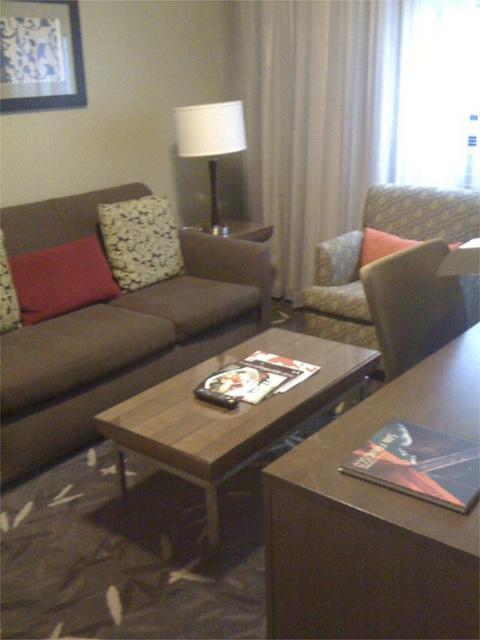Is this a small living room?
Short answer required. Yes. Is the lamp on or off?
Be succinct. Off. What is the floor made out of?
Keep it brief. Carpet. Is this area tidy?
Be succinct. Yes. Is there a laptop on the floor?
Write a very short answer. No. What is reflected in the artwork on the  wall?
Be succinct. Light. 